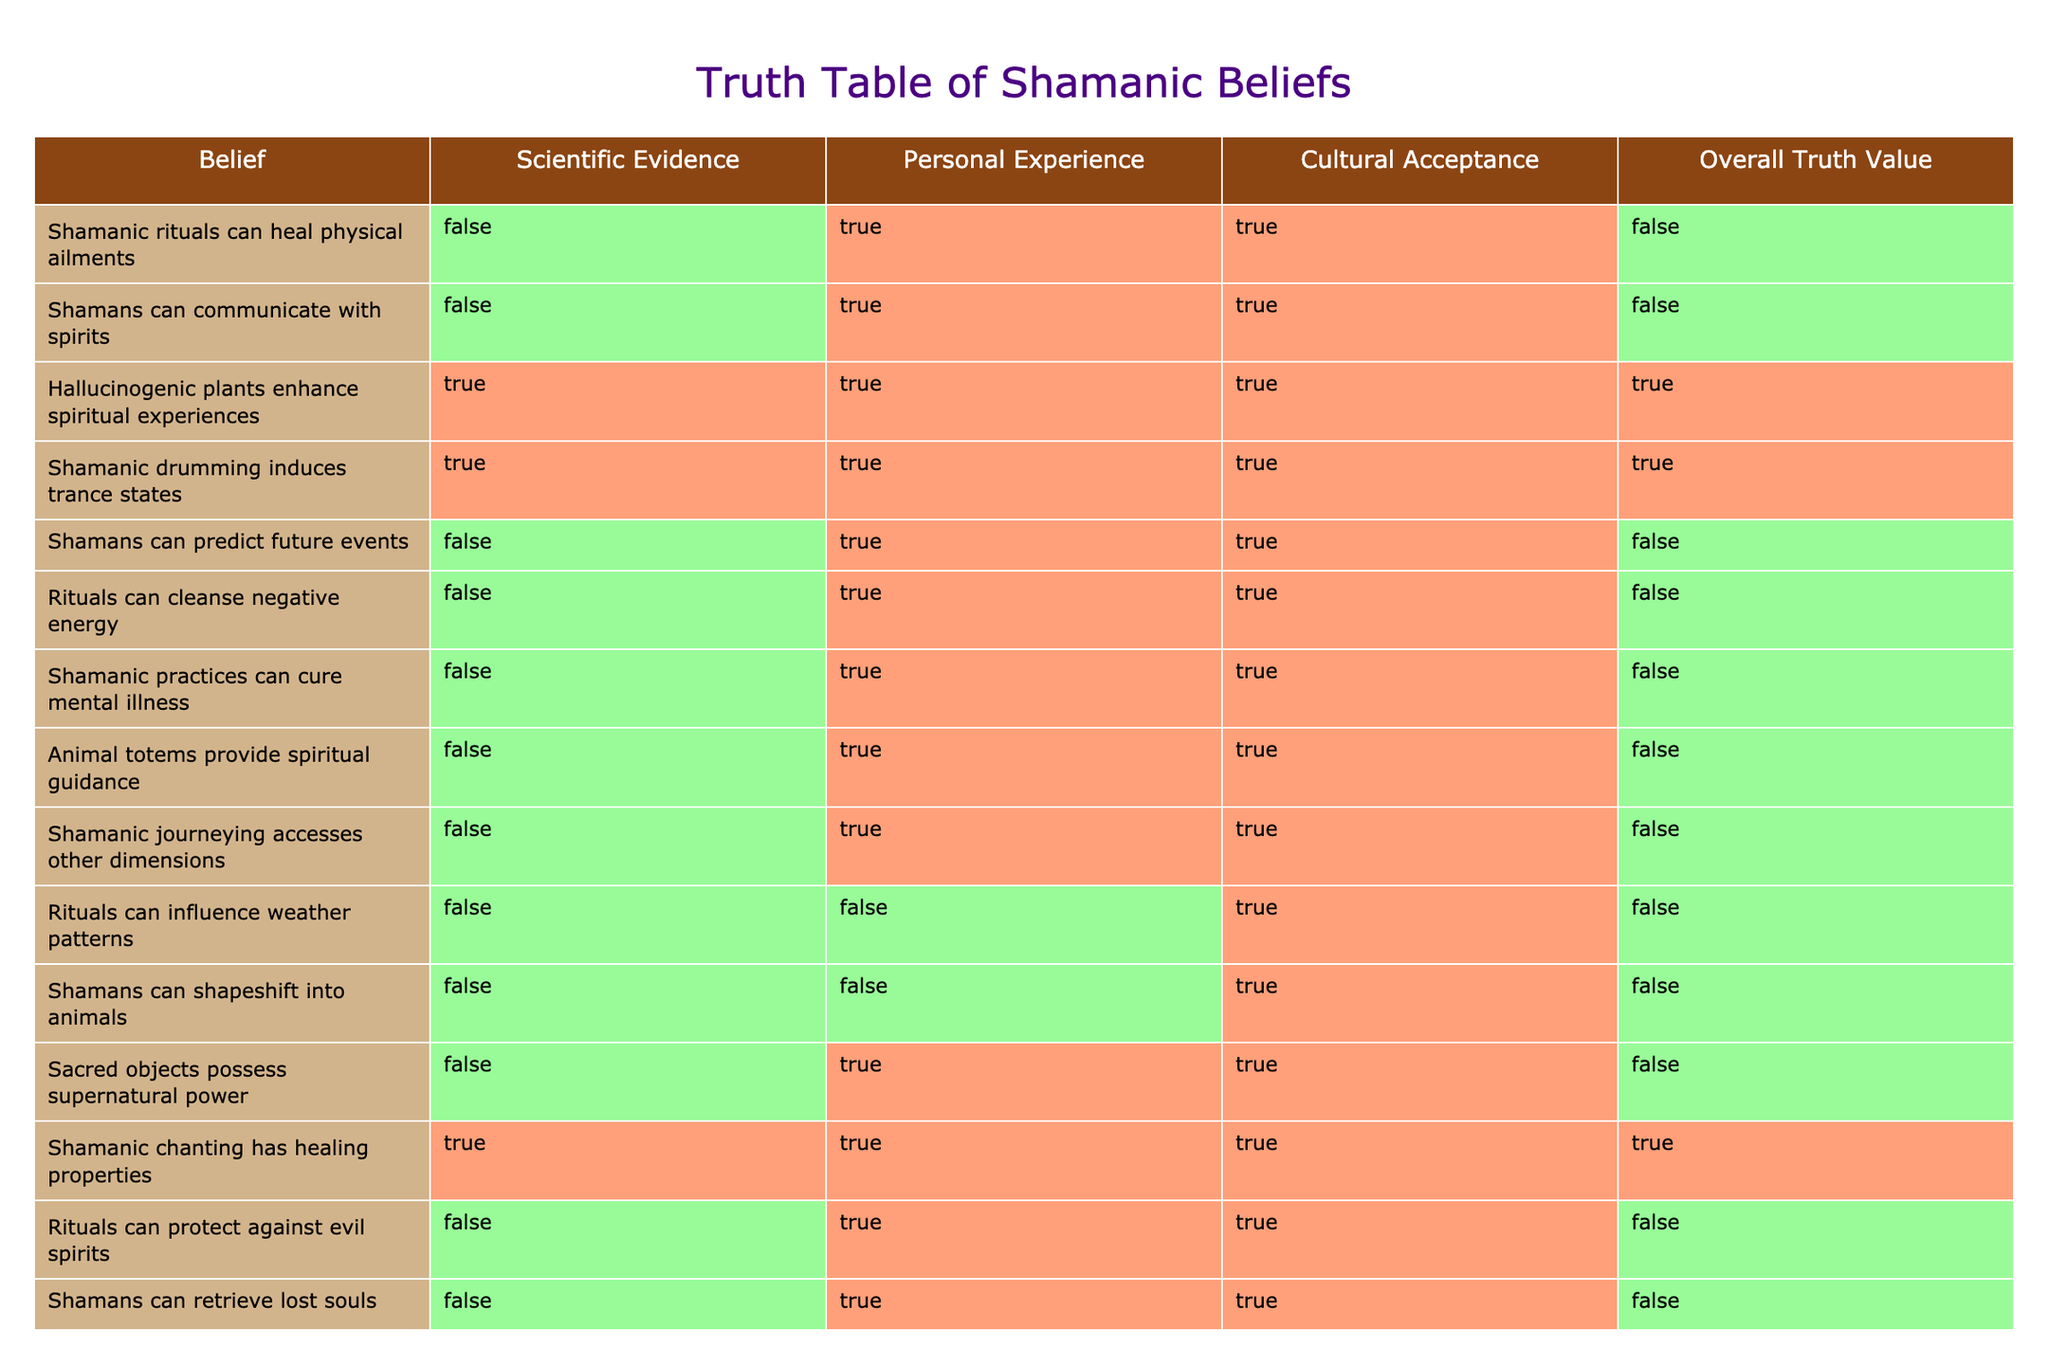What is the truth value of the belief that shamanic rituals can heal physical ailments? According to the table, the belief that shamanic rituals can heal physical ailments has an overall truth value of False. This conclusion is drawn from the fact that scientific evidence for this belief is listed as False, even though both personal experience and cultural acceptance are True.
Answer: False How many beliefs claim that shamans can communicate with spirits and have both personal experience and cultural acceptance as True? The belief that shamans can communicate with spirits is one of the beliefs where both personal experience and cultural acceptance are True. There are a total of 7 beliefs in the table that meet this criterion: 'Shamanic rituals can heal physical ailments,' 'Shamans can communicate with spirits,' 'Hallucinogenic plants enhance spiritual experiences,' 'Shamanic drumming induces trance states,' 'Rituals can cleanse negative energy,' 'Animal totems provide spiritual guidance,' and 'Shamanic journeying accesses other dimensions.'
Answer: 8 What percentage of the beliefs have scientific evidence supporting them? Out of the 14 beliefs listed, only 3 beliefs—'Hallucinogenic plants enhance spiritual experiences,' 'Shamanic drumming induces trance states,' and 'Shamanic chanting has healing properties'—are supported by scientific evidence (True). The percentage can be calculated as (3/14) * 100, which equals approximately 21.43%.
Answer: 21.43% Which belief has the highest overall truth value based on cultural acceptance? The belief with the highest overall truth value based on cultural acceptance is 'Hallucinogenic plants enhance spiritual experiences,' 'Shamanic drumming induces trance states,' and 'Shamanic chanting has healing properties,' all of which have an overall truth value of True. This means they are accepted culturally and also have positive personal experiences associated, along with scientific backing for the last two.
Answer: 'Hallucinogenic plants enhance spiritual experiences,' 'Shamanic drumming induces trance states,' 'Shamanic chanting has healing properties' Is there a belief that can predict future events, and what is its overall truth value? Yes, there is a belief stating that shamans can predict future events. Its overall truth value is False. This belief has False scientific evidence, but it holds True for personal experience and cultural acceptance, leading to its overall false classification.
Answer: False What is the truth value of 'Rituals can protect against evil spirits'? The truth value of 'Rituals can protect against evil spirits' is False. This is concluded from the scientific evidence being False, although personal experience and cultural acceptance are True, which does not suffice to give it a true overall value.
Answer: False 